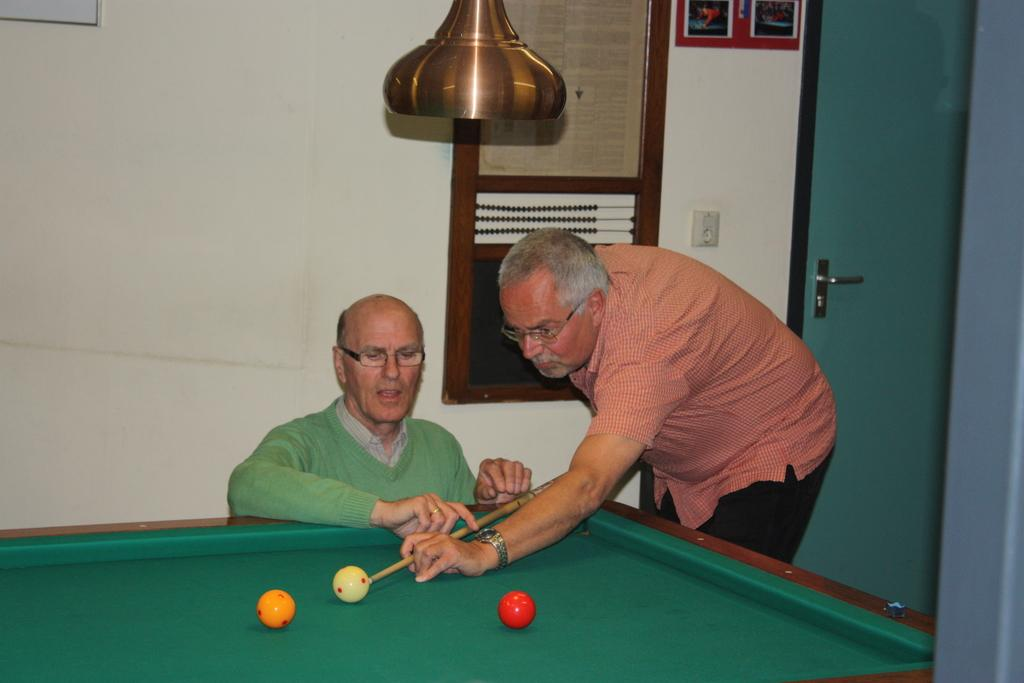What is the main object in the background of the image? There is a frame over a wall in the background, which is likely a door. What are the two men in the image doing? The men are playing a snookers game. What can be observed about the appearance of the men? Both men are wearing spectacles. What is the rate of ice melting in the image? There is no ice present in the image, so it is not possible to determine the rate of ice melting. 